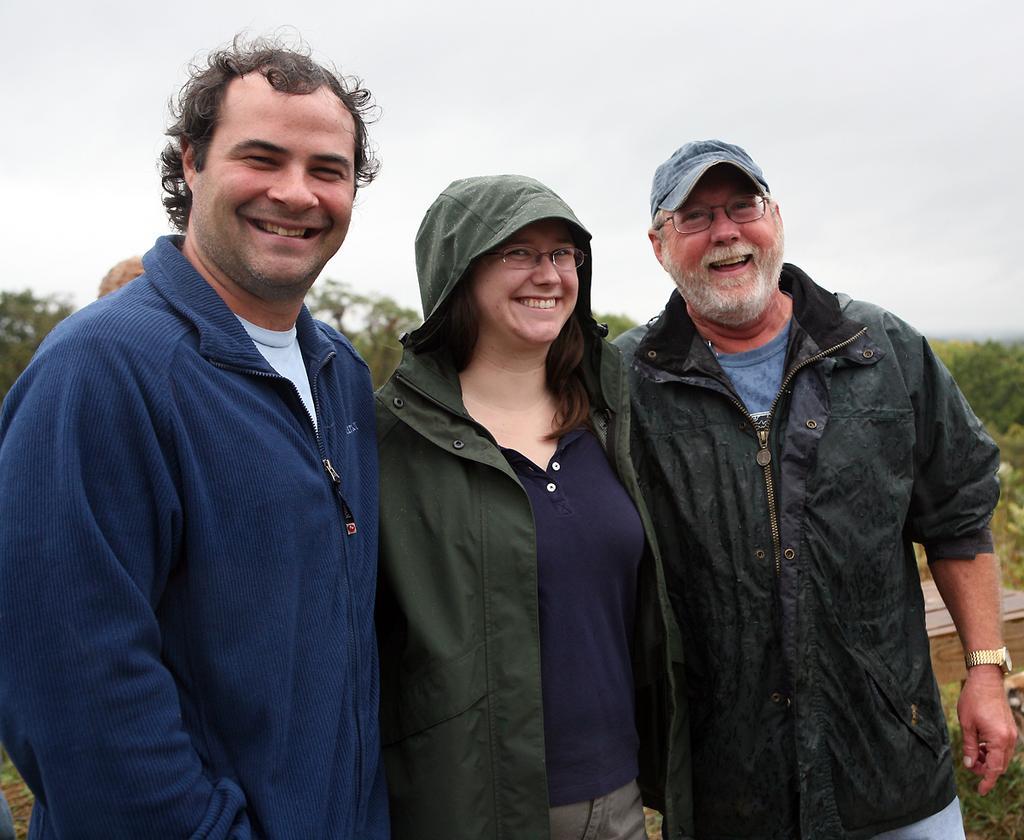Could you give a brief overview of what you see in this image? In the foreground of the picture there are three people standing, they are smiling. On the right there are plants and a box. In the background there are trees and sky. 